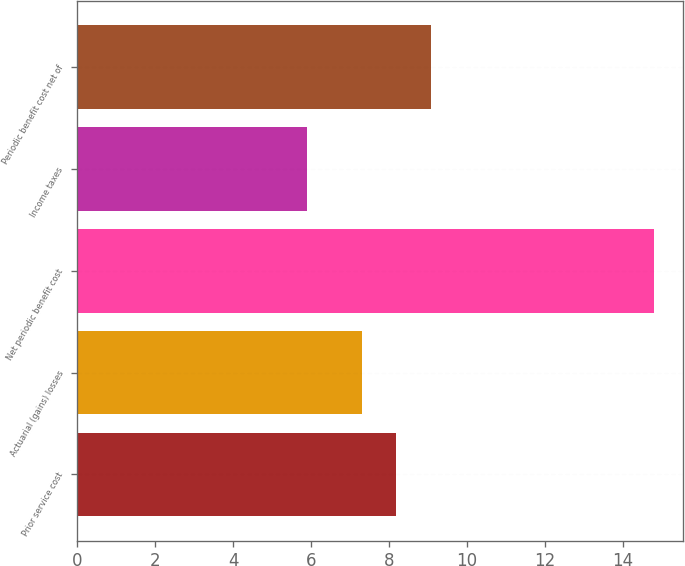Convert chart to OTSL. <chart><loc_0><loc_0><loc_500><loc_500><bar_chart><fcel>Prior service cost<fcel>Actuarial (gains) losses<fcel>Net periodic benefit cost<fcel>Income taxes<fcel>Periodic benefit cost net of<nl><fcel>8.19<fcel>7.3<fcel>14.8<fcel>5.9<fcel>9.08<nl></chart> 